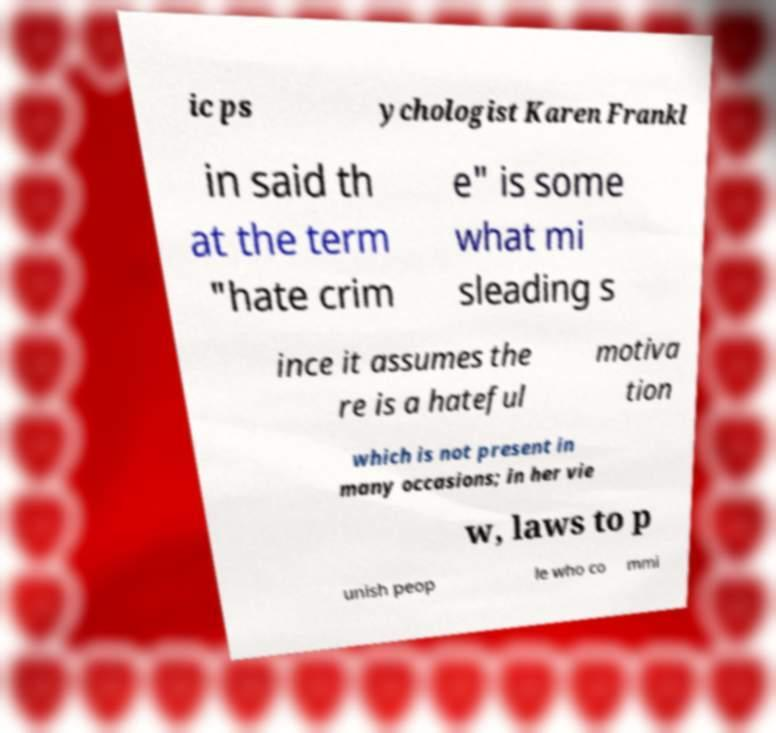Can you accurately transcribe the text from the provided image for me? ic ps ychologist Karen Frankl in said th at the term "hate crim e" is some what mi sleading s ince it assumes the re is a hateful motiva tion which is not present in many occasions; in her vie w, laws to p unish peop le who co mmi 